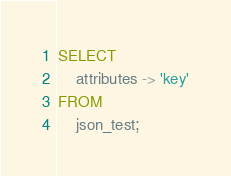<code> <loc_0><loc_0><loc_500><loc_500><_SQL_>SELECT
    attributes -> 'key'
FROM
    json_test;

</code> 